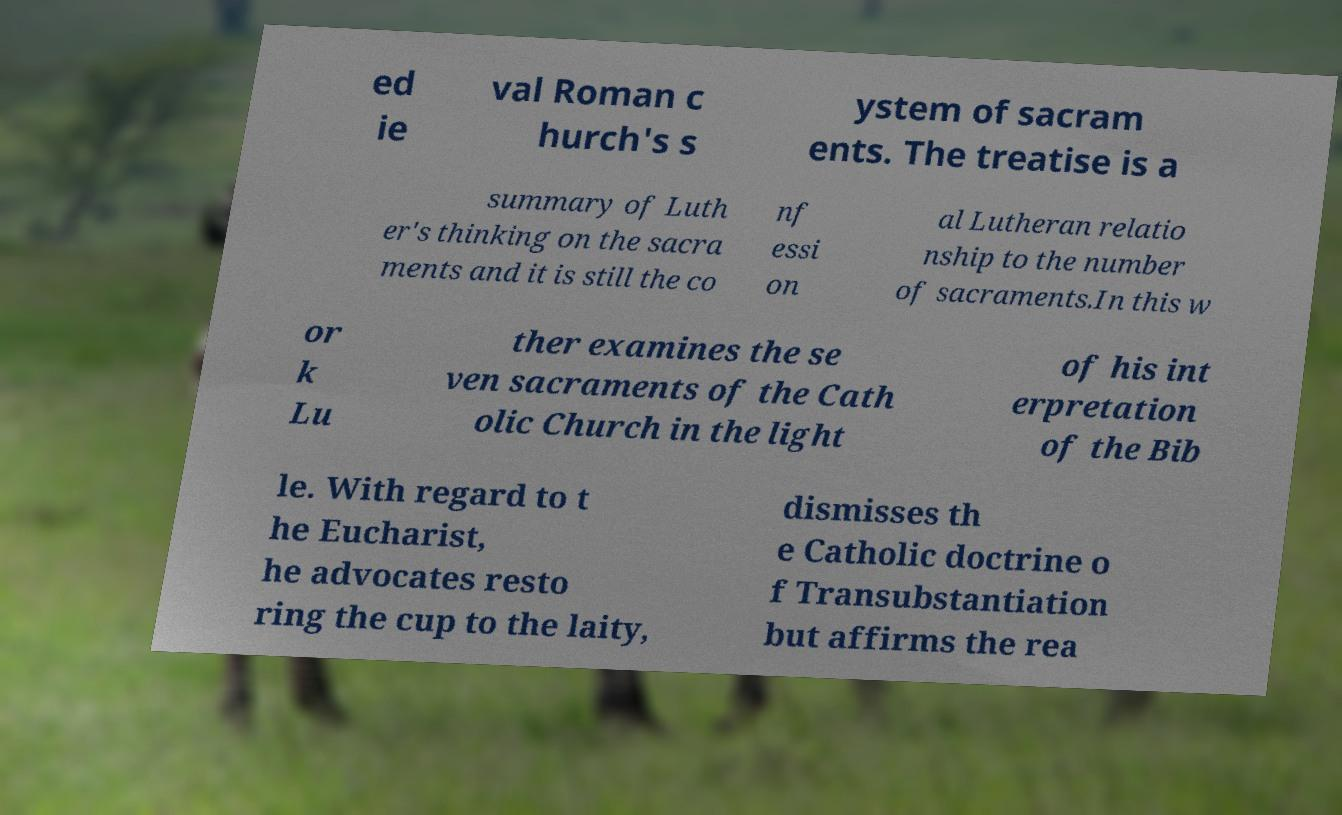What messages or text are displayed in this image? I need them in a readable, typed format. ed ie val Roman c hurch's s ystem of sacram ents. The treatise is a summary of Luth er's thinking on the sacra ments and it is still the co nf essi on al Lutheran relatio nship to the number of sacraments.In this w or k Lu ther examines the se ven sacraments of the Cath olic Church in the light of his int erpretation of the Bib le. With regard to t he Eucharist, he advocates resto ring the cup to the laity, dismisses th e Catholic doctrine o f Transubstantiation but affirms the rea 